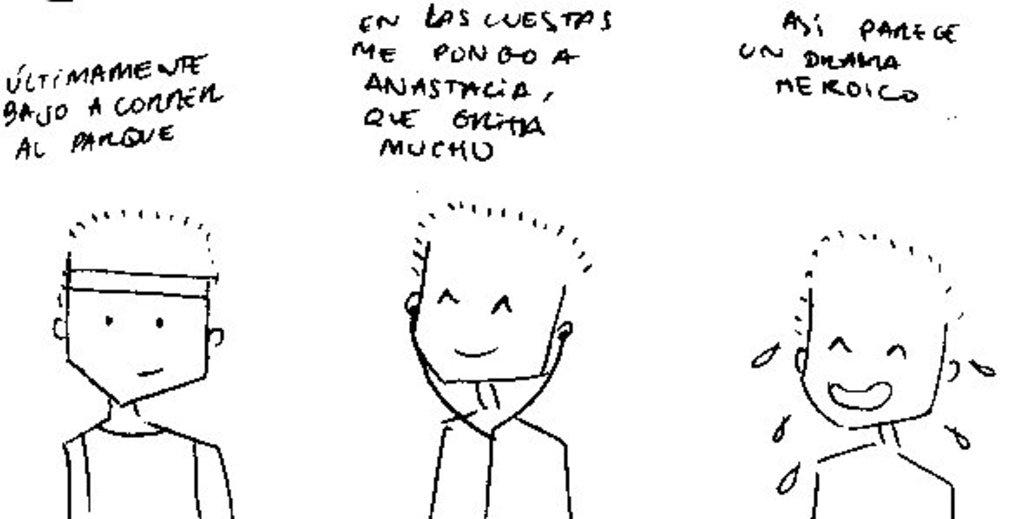What is depicted in the image? There are drawings of persons in the image. What else is present in the image besides the drawings of persons? There is text in the image. Can you tell me how many rabbits are visible in the image? There are no rabbits present in the image; it features drawings of persons and text. What type of camera is being used to take the picture in the image? There is no camera visible in the image, as it is a drawing or illustration of persons and text. 